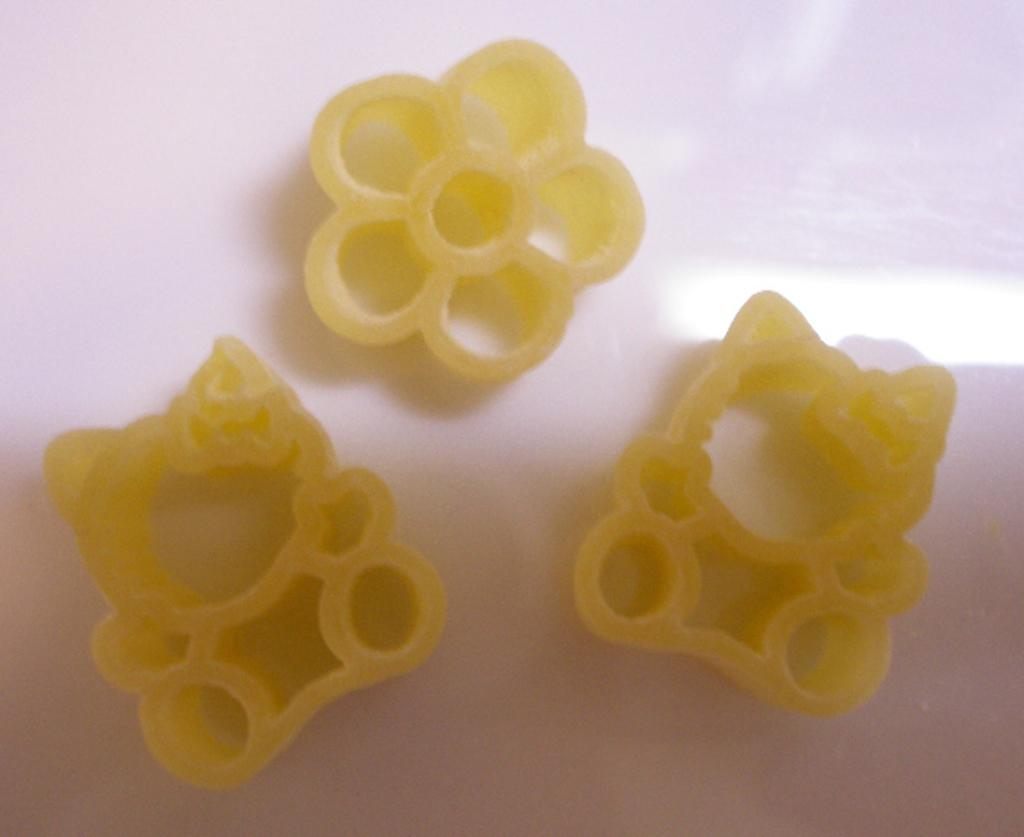What type of food is shown in the image? There are three pasta items in the image. Where are the pasta items located? The pasta items are on a platform. What type of cork can be seen in the image? There is no cork present in the image; it features three pasta items on a platform. 